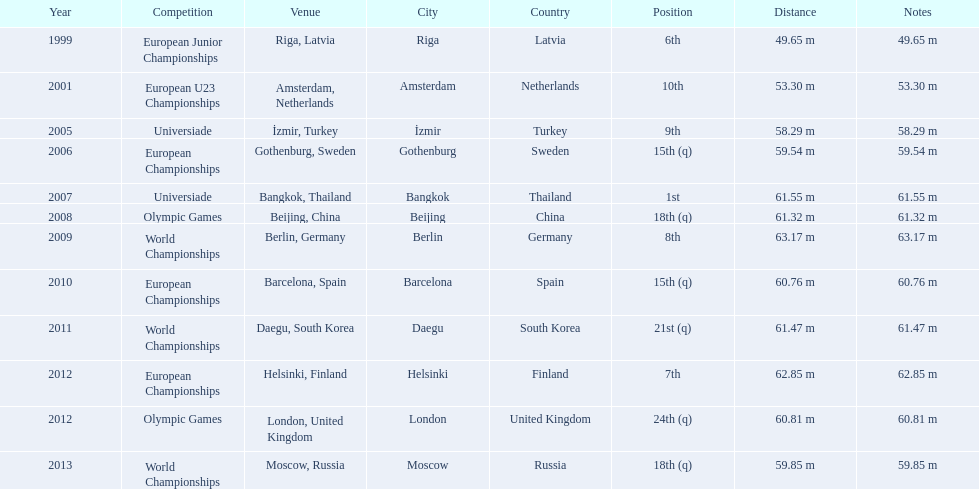What are the years that gerhard mayer participated? 1999, 2001, 2005, 2006, 2007, 2008, 2009, 2010, 2011, 2012, 2012, 2013. Which years were earlier than 2007? 1999, 2001, 2005, 2006. What was the best placing for these years? 6th. 